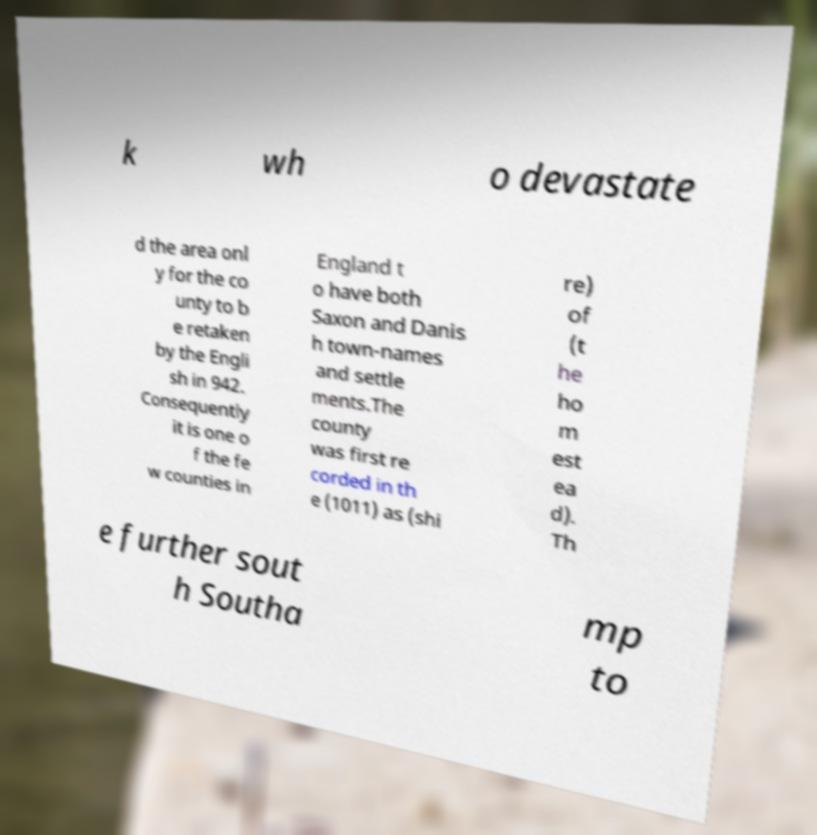Please identify and transcribe the text found in this image. k wh o devastate d the area onl y for the co unty to b e retaken by the Engli sh in 942. Consequently it is one o f the fe w counties in England t o have both Saxon and Danis h town-names and settle ments.The county was first re corded in th e (1011) as (shi re) of (t he ho m est ea d). Th e further sout h Southa mp to 